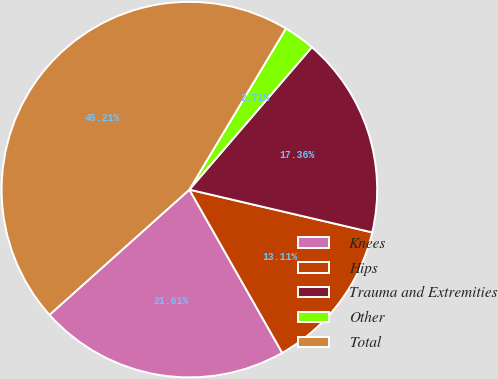Convert chart. <chart><loc_0><loc_0><loc_500><loc_500><pie_chart><fcel>Knees<fcel>Hips<fcel>Trauma and Extremities<fcel>Other<fcel>Total<nl><fcel>21.61%<fcel>13.11%<fcel>17.36%<fcel>2.71%<fcel>45.21%<nl></chart> 